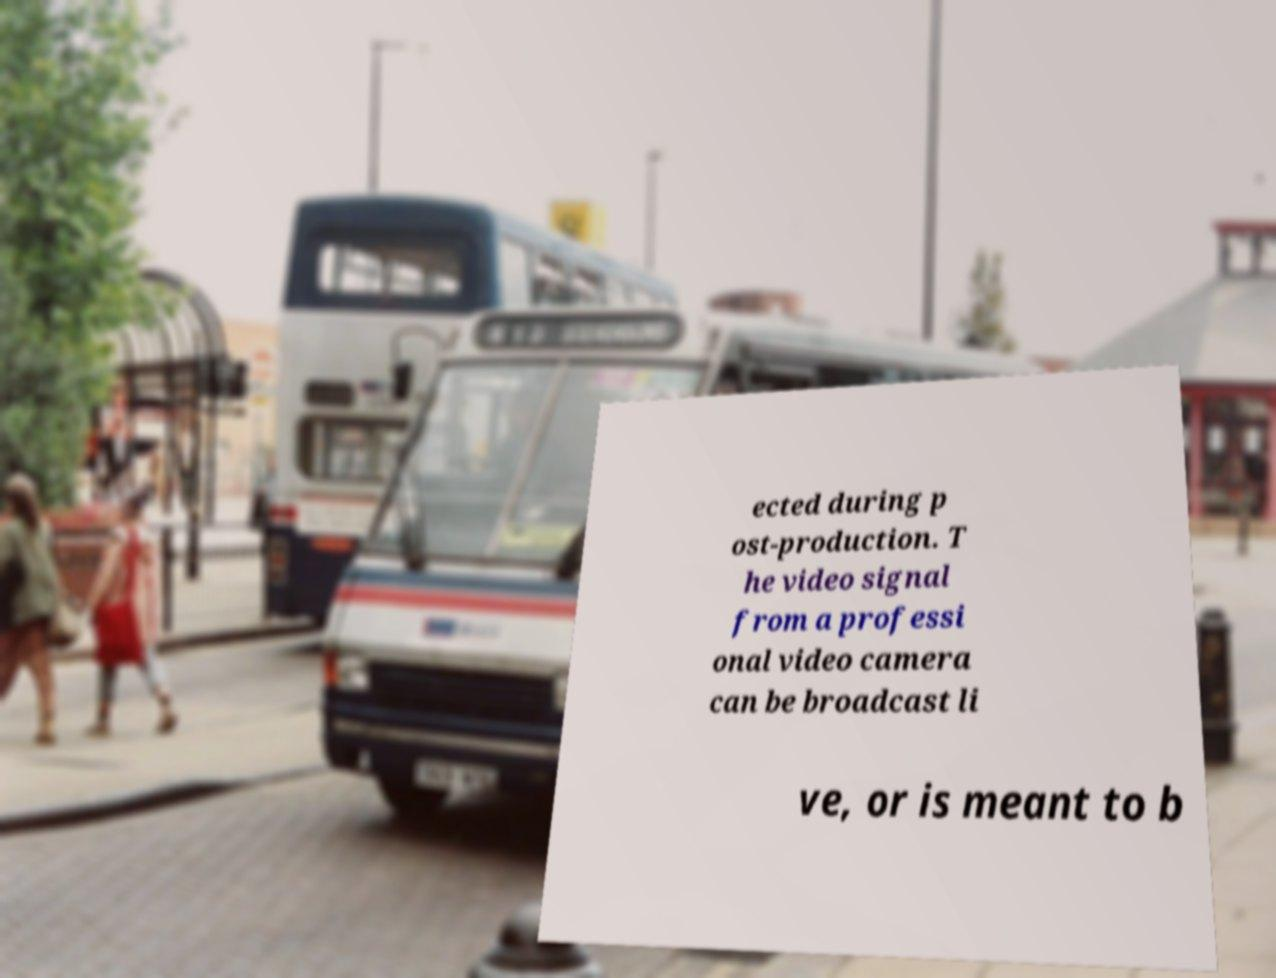Please read and relay the text visible in this image. What does it say? ected during p ost-production. T he video signal from a professi onal video camera can be broadcast li ve, or is meant to b 